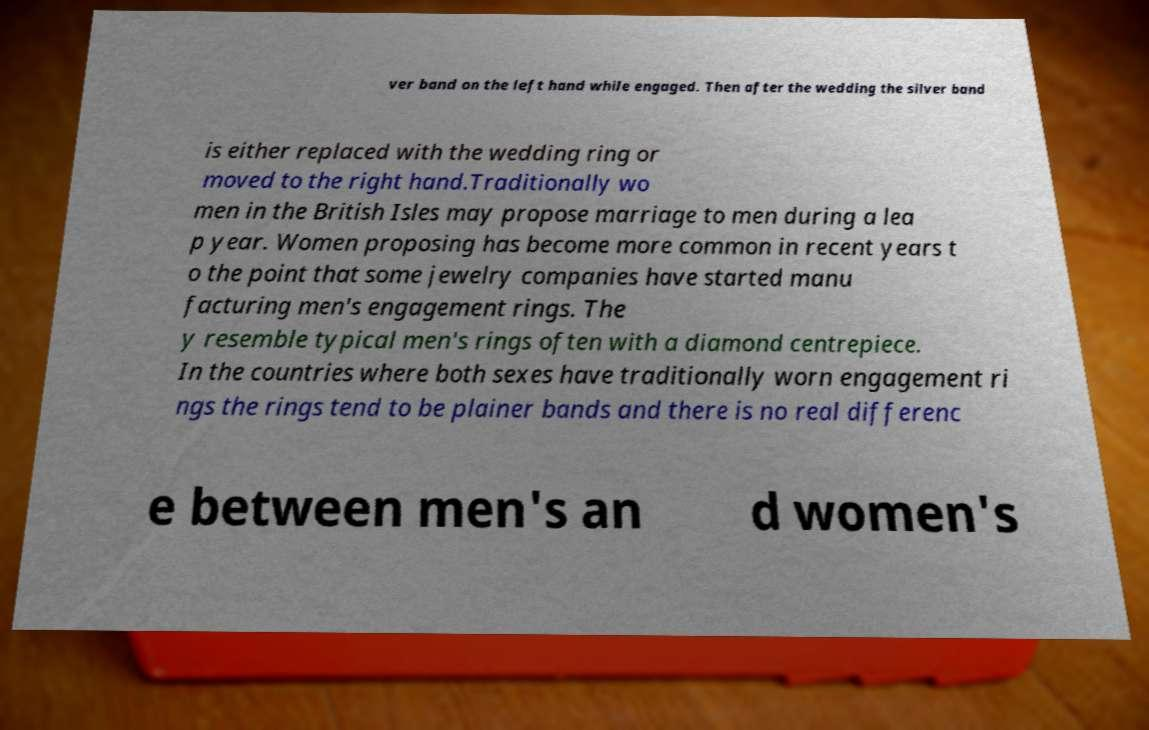I need the written content from this picture converted into text. Can you do that? ver band on the left hand while engaged. Then after the wedding the silver band is either replaced with the wedding ring or moved to the right hand.Traditionally wo men in the British Isles may propose marriage to men during a lea p year. Women proposing has become more common in recent years t o the point that some jewelry companies have started manu facturing men's engagement rings. The y resemble typical men's rings often with a diamond centrepiece. In the countries where both sexes have traditionally worn engagement ri ngs the rings tend to be plainer bands and there is no real differenc e between men's an d women's 